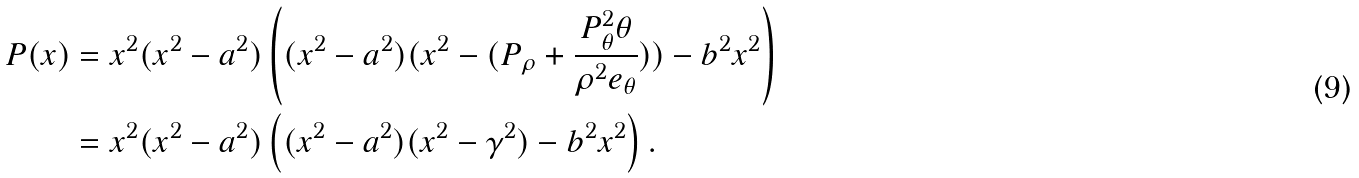<formula> <loc_0><loc_0><loc_500><loc_500>P ( x ) & = x ^ { 2 } ( x ^ { 2 } - a ^ { 2 } ) \left ( ( x ^ { 2 } - a ^ { 2 } ) ( x ^ { 2 } - ( P _ { \rho } + \frac { P _ { \theta } ^ { 2 } \theta } { \rho ^ { 2 } e _ { \theta } } ) ) - b ^ { 2 } x ^ { 2 } \right ) \\ & = x ^ { 2 } ( x ^ { 2 } - a ^ { 2 } ) \left ( ( x ^ { 2 } - a ^ { 2 } ) ( x ^ { 2 } - \gamma ^ { 2 } ) - b ^ { 2 } x ^ { 2 } \right ) .</formula> 